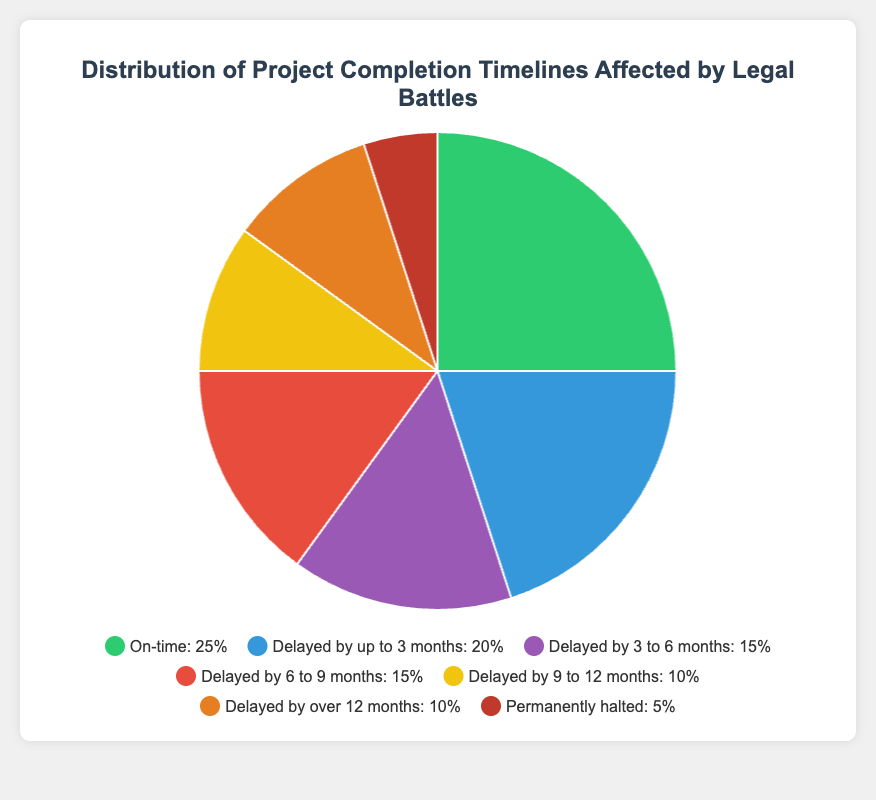What's the combined percentage of projects that were either delayed by up to 3 months or permanently halted? To find the combined percentage, we sum the percentage of projects delayed by up to 3 months (20%) and permanently halted (5%): 20% + 5% = 25%.
Answer: 25% Which category has the highest proportion of projects? By visually inspecting the pie chart, the largest segment is for "On-time" projects, which has a percentage of 25%.
Answer: On-time How much higher is the percentage of projects delayed by up to 3 months compared to those delayed by over 12 months? To find this, subtract the percentage of projects delayed by over 12 months (10%) from those delayed by up to 3 months (20%): 20% - 10% = 10%.
Answer: 10% What is the least represented category in the chart? The smallest slice in the pie chart corresponds to the "Permanently halted" category, which has a percentage of 5%.
Answer: Permanently halted What's the total percentage of projects that faced delays longer than 6 months? To find this, sum the percentages of projects delayed by 6 to 9 months (15%), 9 to 12 months (10%), and over 12 months (10%): 15% + 10% + 10% = 35%.
Answer: 35% Compare the percentage of projects delayed by 3 to 9 months to those that are on-time. Which is higher and by how much? First, sum the percentages of projects delayed by 3 to 6 months (15%) and 6 to 9 months (15%): 15% + 15% = 30%. The percentage for on-time projects is 25%. The delayed percentage (30%) is higher by 30% - 25% = 5%.
Answer: Delayed by 5% How many categories have a percentage greater than or equal to 15%? By inspecting the chart, the categories with percentages equal to or greater than 15% are "On-time" (25%), "Delayed by up to 3 months" (20%), "Delayed by 3 to 6 months" (15%), and "Delayed by 6 to 9 months" (15%). This gives us 4 categories.
Answer: 4 Looking at the visual attributes, what color represents the "Delayed by 6 to 9 months" category? In the legend, the color used for "Delayed by 6 to 9 months" is identified as the fourth color, which is red in the pie chart's color palette.
Answer: Red 